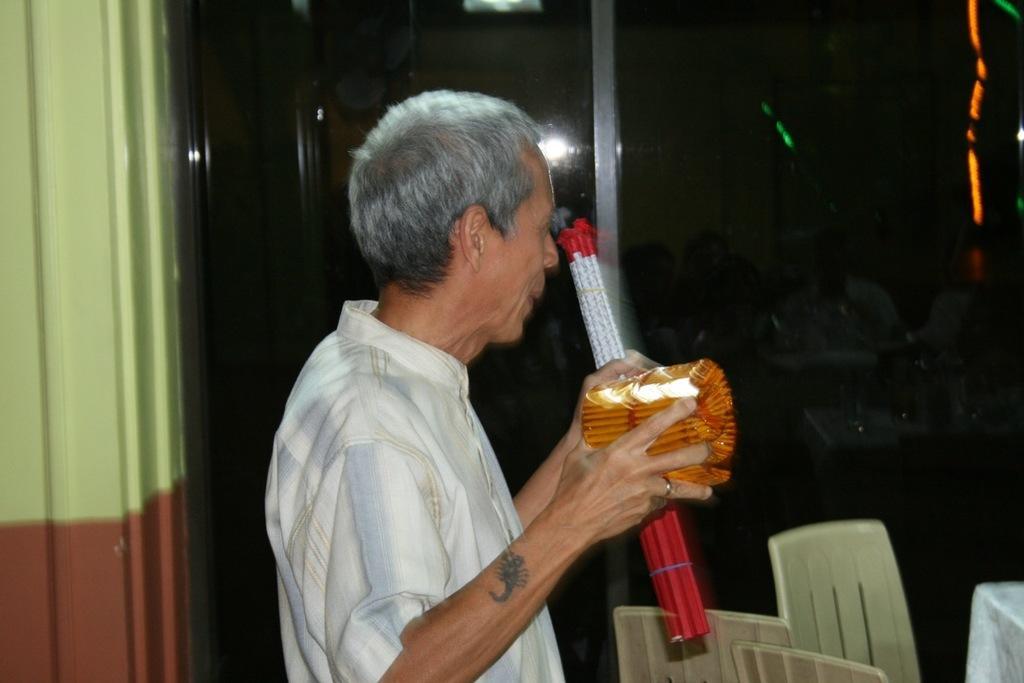How would you summarize this image in a sentence or two? In the foreground of this image, there is a man standing and holding few objects. In the background, there is a glass and at the bottom, there are chairs and a cloth like an object on the right. 